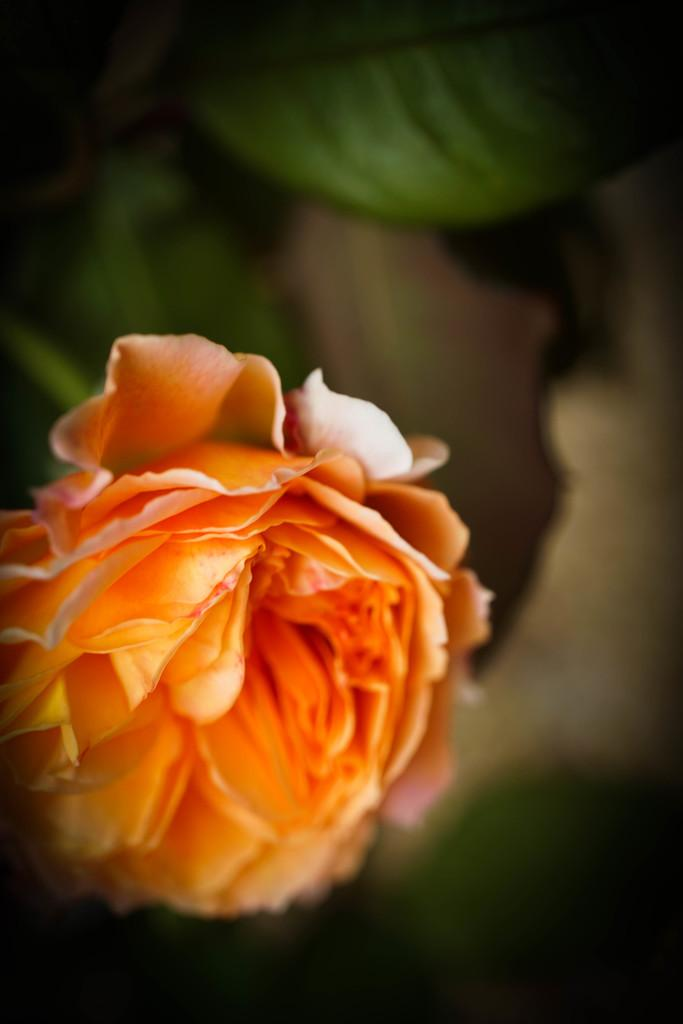What is the main subject of the image? There is a flower in the image. What type of engine is powering the flower in the image? There is: There is no engine present in the image, as it features a flower. 